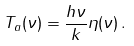<formula> <loc_0><loc_0><loc_500><loc_500>T _ { a } ( \nu ) = \frac { h \nu } { k } \eta ( \nu ) \, .</formula> 